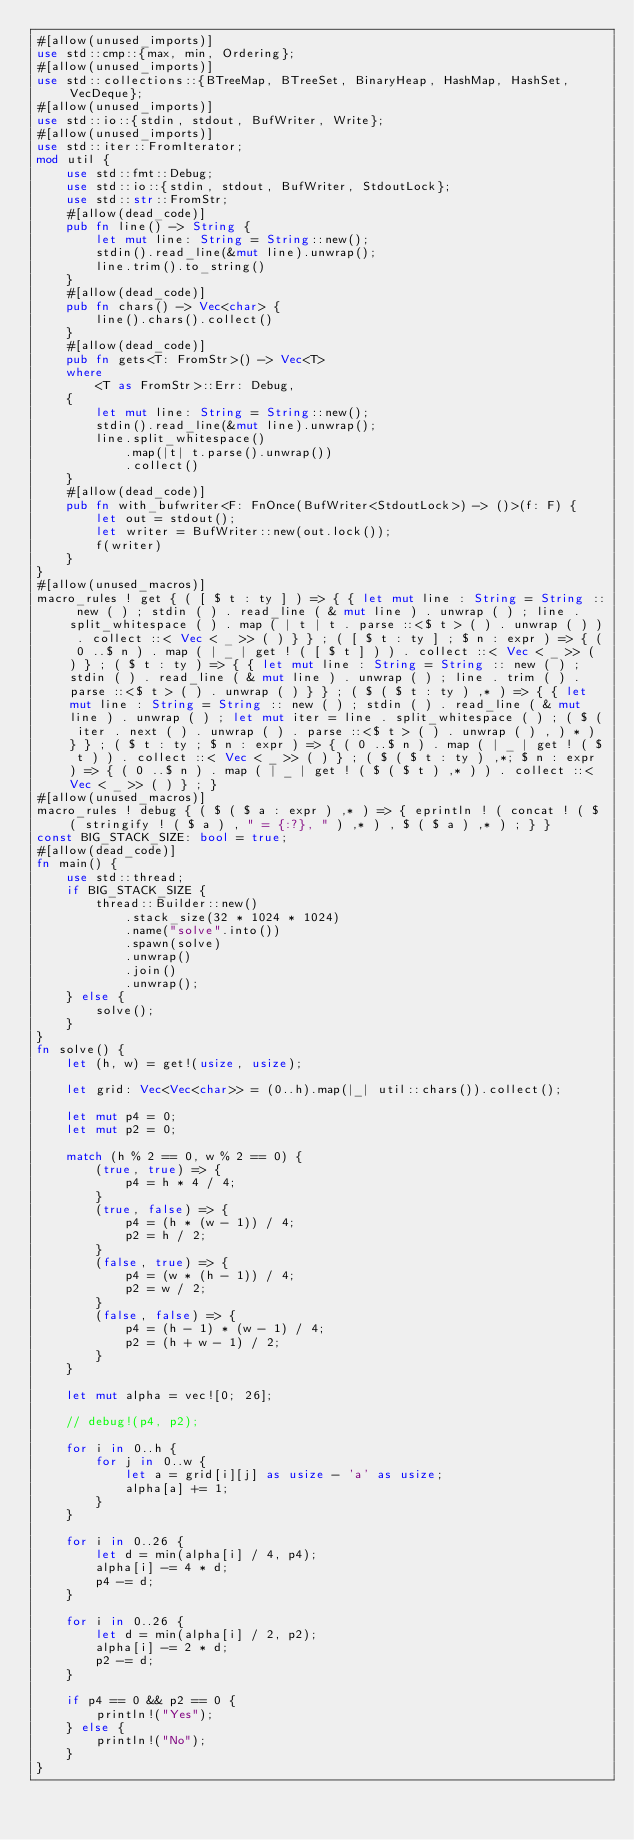Convert code to text. <code><loc_0><loc_0><loc_500><loc_500><_Rust_>#[allow(unused_imports)]
use std::cmp::{max, min, Ordering};
#[allow(unused_imports)]
use std::collections::{BTreeMap, BTreeSet, BinaryHeap, HashMap, HashSet, VecDeque};
#[allow(unused_imports)]
use std::io::{stdin, stdout, BufWriter, Write};
#[allow(unused_imports)]
use std::iter::FromIterator;
mod util {
    use std::fmt::Debug;
    use std::io::{stdin, stdout, BufWriter, StdoutLock};
    use std::str::FromStr;
    #[allow(dead_code)]
    pub fn line() -> String {
        let mut line: String = String::new();
        stdin().read_line(&mut line).unwrap();
        line.trim().to_string()
    }
    #[allow(dead_code)]
    pub fn chars() -> Vec<char> {
        line().chars().collect()
    }
    #[allow(dead_code)]
    pub fn gets<T: FromStr>() -> Vec<T>
    where
        <T as FromStr>::Err: Debug,
    {
        let mut line: String = String::new();
        stdin().read_line(&mut line).unwrap();
        line.split_whitespace()
            .map(|t| t.parse().unwrap())
            .collect()
    }
    #[allow(dead_code)]
    pub fn with_bufwriter<F: FnOnce(BufWriter<StdoutLock>) -> ()>(f: F) {
        let out = stdout();
        let writer = BufWriter::new(out.lock());
        f(writer)
    }
}
#[allow(unused_macros)]
macro_rules ! get { ( [ $ t : ty ] ) => { { let mut line : String = String :: new ( ) ; stdin ( ) . read_line ( & mut line ) . unwrap ( ) ; line . split_whitespace ( ) . map ( | t | t . parse ::<$ t > ( ) . unwrap ( ) ) . collect ::< Vec < _ >> ( ) } } ; ( [ $ t : ty ] ; $ n : expr ) => { ( 0 ..$ n ) . map ( | _ | get ! ( [ $ t ] ) ) . collect ::< Vec < _ >> ( ) } ; ( $ t : ty ) => { { let mut line : String = String :: new ( ) ; stdin ( ) . read_line ( & mut line ) . unwrap ( ) ; line . trim ( ) . parse ::<$ t > ( ) . unwrap ( ) } } ; ( $ ( $ t : ty ) ,* ) => { { let mut line : String = String :: new ( ) ; stdin ( ) . read_line ( & mut line ) . unwrap ( ) ; let mut iter = line . split_whitespace ( ) ; ( $ ( iter . next ( ) . unwrap ( ) . parse ::<$ t > ( ) . unwrap ( ) , ) * ) } } ; ( $ t : ty ; $ n : expr ) => { ( 0 ..$ n ) . map ( | _ | get ! ( $ t ) ) . collect ::< Vec < _ >> ( ) } ; ( $ ( $ t : ty ) ,*; $ n : expr ) => { ( 0 ..$ n ) . map ( | _ | get ! ( $ ( $ t ) ,* ) ) . collect ::< Vec < _ >> ( ) } ; }
#[allow(unused_macros)]
macro_rules ! debug { ( $ ( $ a : expr ) ,* ) => { eprintln ! ( concat ! ( $ ( stringify ! ( $ a ) , " = {:?}, " ) ,* ) , $ ( $ a ) ,* ) ; } }
const BIG_STACK_SIZE: bool = true;
#[allow(dead_code)]
fn main() {
    use std::thread;
    if BIG_STACK_SIZE {
        thread::Builder::new()
            .stack_size(32 * 1024 * 1024)
            .name("solve".into())
            .spawn(solve)
            .unwrap()
            .join()
            .unwrap();
    } else {
        solve();
    }
}
fn solve() {
    let (h, w) = get!(usize, usize);

    let grid: Vec<Vec<char>> = (0..h).map(|_| util::chars()).collect();

    let mut p4 = 0;
    let mut p2 = 0;

    match (h % 2 == 0, w % 2 == 0) {
        (true, true) => {
            p4 = h * 4 / 4;
        }
        (true, false) => {
            p4 = (h * (w - 1)) / 4;
            p2 = h / 2;
        }
        (false, true) => {
            p4 = (w * (h - 1)) / 4;
            p2 = w / 2;
        }
        (false, false) => {
            p4 = (h - 1) * (w - 1) / 4;
            p2 = (h + w - 1) / 2;
        }
    }

    let mut alpha = vec![0; 26];

    // debug!(p4, p2);

    for i in 0..h {
        for j in 0..w {
            let a = grid[i][j] as usize - 'a' as usize;
            alpha[a] += 1;
        }
    }

    for i in 0..26 {
        let d = min(alpha[i] / 4, p4);
        alpha[i] -= 4 * d;
        p4 -= d;
    }

    for i in 0..26 {
        let d = min(alpha[i] / 2, p2);
        alpha[i] -= 2 * d;
        p2 -= d;
    }

    if p4 == 0 && p2 == 0 {
        println!("Yes");
    } else {
        println!("No");
    }
}
</code> 